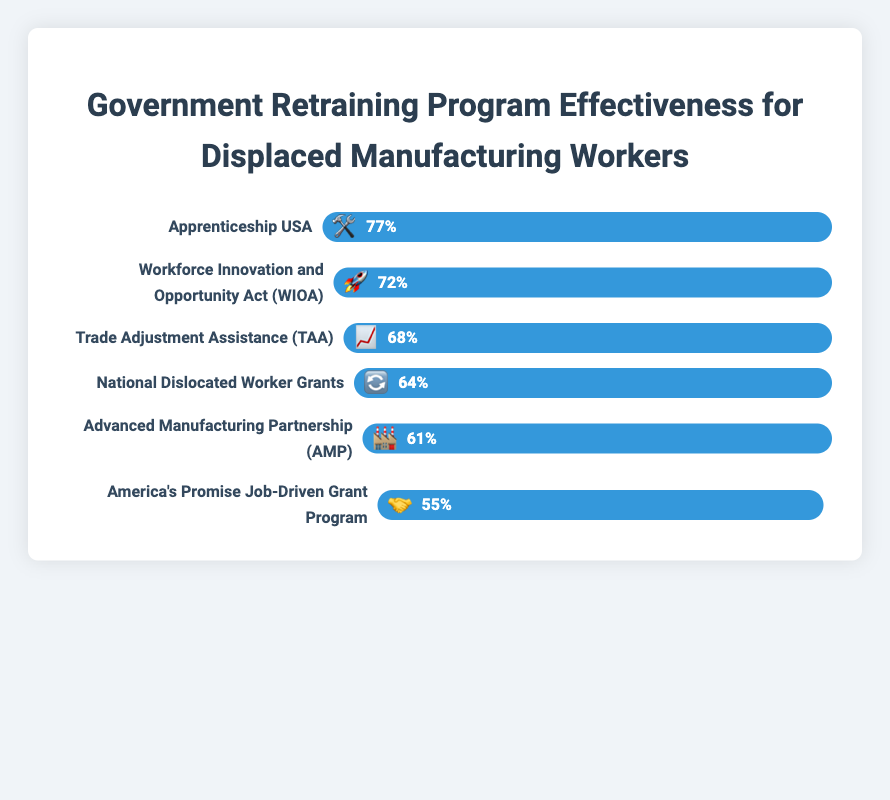How many programs have a success rate above 70%? Let's count the programs that have a bar value greater than 70%: "Apprenticeship USA" at 77% and "Workforce Innovation and Opportunity Act (WIOA)" at 72%. So there are 2 programs.
Answer: 2 Which program has the lowest success rate, and what emoji does it use? Look at the bar with the smallest width, which belongs to "America's Promise Job-Driven Grant Program," with a 55% success rate. The emoji used is 🤝.
Answer: America's Promise Job-Driven Grant Program, 🤝 What's the difference in success rates between the top two most effective programs? The top two programs are "Apprenticeship USA" at 77% and "Workforce Innovation and Opportunity Act (WIOA)" at 72%. Subtracting these gives 77% - 72% = 5%.
Answer: 5% Which program is represented by the emoji 🛠️ and what is its success rate? The emoji 🛠️ represents the "Apprenticeship USA" program, which has a 77% success rate.
Answer: Apprenticeship USA, 77% What is the average success rate of all the programs? To find the average: (77 + 72 + 68 + 64 + 61 + 55) / 6 = 397 / 6 ≈ 66.17%
Answer: 66.17% How does the "Trade Adjustment Assistance (TAA)" program's success rate compare to the "National Dislocated Worker Grants"? The success rate of "Trade Adjustment Assistance (TAA)" is 68%, and "National Dislocated Worker Grants" is 64%. 68% is higher than 64%.
Answer: TAA is higher If the "Advanced Manufacturing Partnership (AMP)" program improved its success rate to match that of "Workforce Innovation and Opportunity Act (WIOA)," what would be the increase in its success rate? The current rate of AMP is 61%, and WIOA is at 72%. The increase would be 72% - 61% = 11%.
Answer: 11% Which program falls exactly in the middle in terms of success rate? Listing the programs by success rate: 55%, 61%, 64%, 68%, 72%, 77%. The middle values are 64% and 68%. The "National Dislocated Worker Grants" and "Trade Adjustment Assistance (TAA)" both fall in the middle.
Answer: National Dislocated Worker Grants and Trade Adjustment Assistance (TAA) How many programs have a success rate of 60% or higher? Counting the bars with success rates of 60% or more: "Apprenticeship USA," "Workforce Innovation and Opportunity Act (WIOA)," "Trade Adjustment Assistance (TAA)," "National Dislocated Worker Grants," and "Advanced Manufacturing Partnership (AMP)." There are 5 programs.
Answer: 5 